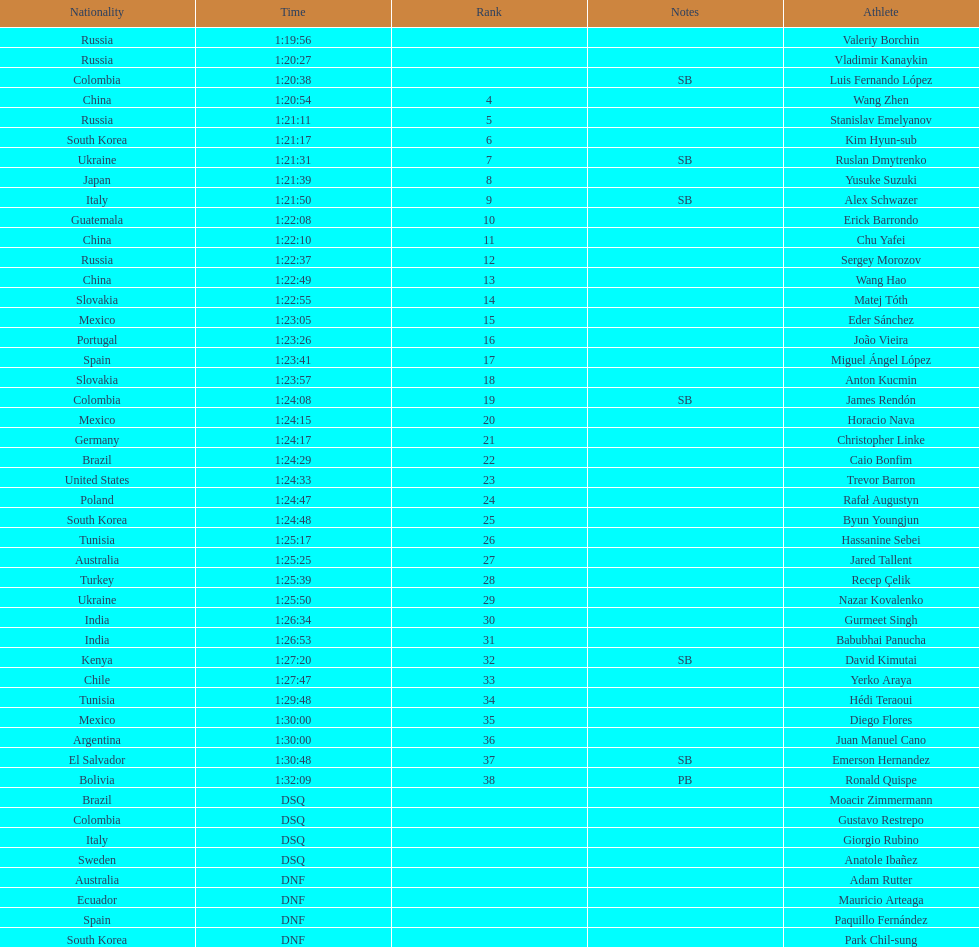Which athlete had the fastest time for the 20km? Valeriy Borchin. 